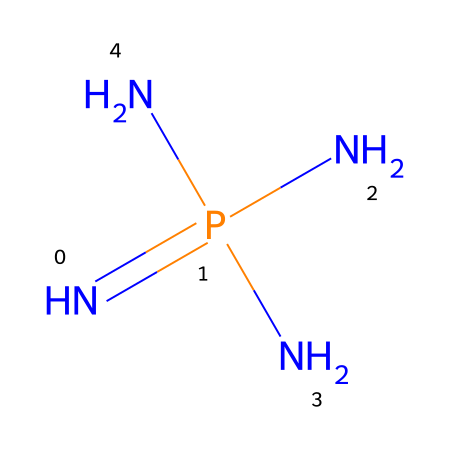What is the main element in this chemical structure? The SMILES representation shows multiple nitrogen atoms (N) and one phosphorus atom (P), indicating that nitrogen is the main element due to its higher count.
Answer: nitrogen How many nitrogen atoms are present? By examining the SMILES structure, there are four nitrogen atoms in total, as indicated by the presence of three N's connected to the phosphorus and one nitrogen atom at the end.
Answer: four What type of bonds are present in this chemical? The structure primarily consists of single bonds connecting nitrogen atoms and phosphorus. No double or triple bonds are represented in the SMILES, indicating that single bonds are predominant.
Answer: single bonds Is this chemical considered a phosphazene base? Yes, the presence of phosphorous and multiple nitrogen atoms in a ring structure is characteristic of phosphazene bases, confirming its classification.
Answer: yes What is the significance of phosphazene bases in cleaning products? Phosphazene bases are known for their high solubility and ability to interact with various substances, which makes them effective as cleaning agents in specialized applications, including theatrical props.
Answer: effectiveness How many total atoms are in the molecule? Adding up the nitrogen(4) and phosphorus(1), we have a total of 5 atoms in the entire structure, combining all elements present in the chemical.
Answer: five 